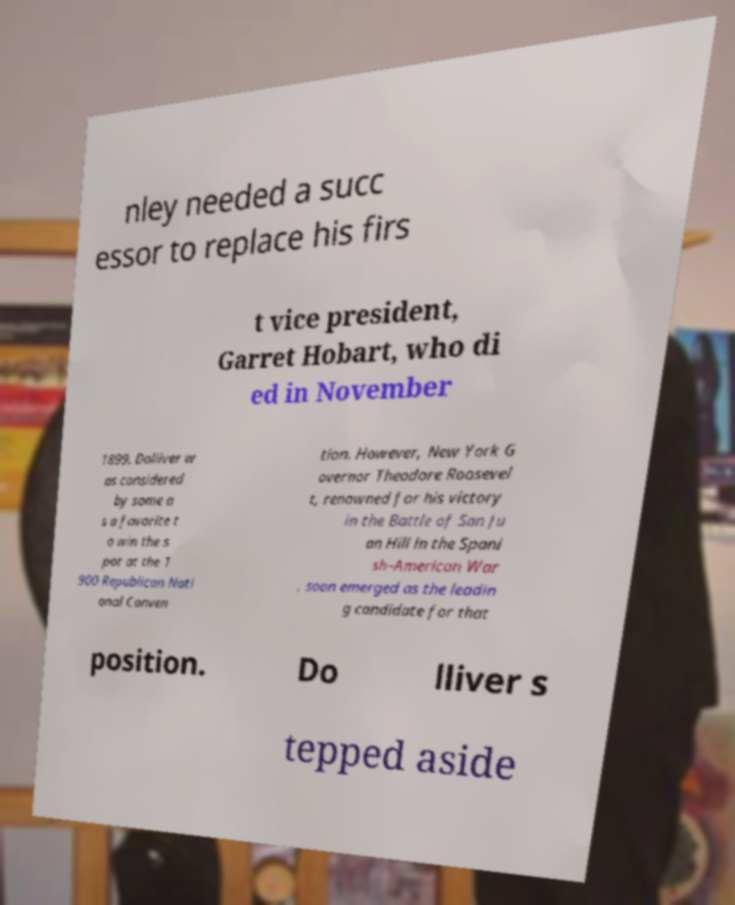Can you read and provide the text displayed in the image?This photo seems to have some interesting text. Can you extract and type it out for me? nley needed a succ essor to replace his firs t vice president, Garret Hobart, who di ed in November 1899. Dolliver w as considered by some a s a favorite t o win the s pot at the 1 900 Republican Nati onal Conven tion. However, New York G overnor Theodore Roosevel t, renowned for his victory in the Battle of San Ju an Hill in the Spani sh–American War , soon emerged as the leadin g candidate for that position. Do lliver s tepped aside 